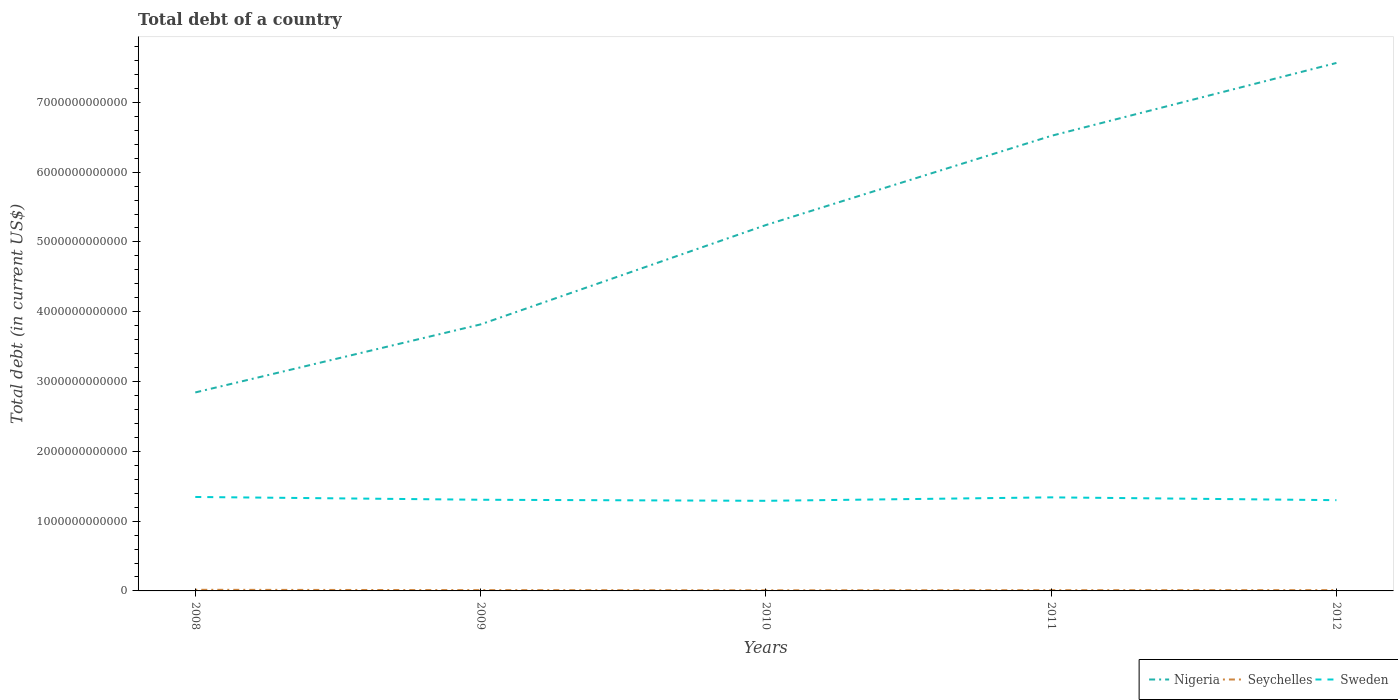Does the line corresponding to Seychelles intersect with the line corresponding to Sweden?
Make the answer very short. No. Is the number of lines equal to the number of legend labels?
Your answer should be compact. Yes. Across all years, what is the maximum debt in Sweden?
Make the answer very short. 1.29e+12. In which year was the debt in Seychelles maximum?
Your response must be concise. 2010. What is the total debt in Sweden in the graph?
Provide a short and direct response. 5.51e+1. What is the difference between the highest and the second highest debt in Seychelles?
Offer a terse response. 7.33e+09. Is the debt in Sweden strictly greater than the debt in Nigeria over the years?
Your answer should be compact. Yes. What is the difference between two consecutive major ticks on the Y-axis?
Provide a short and direct response. 1.00e+12. Are the values on the major ticks of Y-axis written in scientific E-notation?
Make the answer very short. No. Does the graph contain grids?
Your answer should be very brief. No. Where does the legend appear in the graph?
Your answer should be compact. Bottom right. How many legend labels are there?
Your answer should be compact. 3. What is the title of the graph?
Make the answer very short. Total debt of a country. Does "Sierra Leone" appear as one of the legend labels in the graph?
Keep it short and to the point. No. What is the label or title of the Y-axis?
Keep it short and to the point. Total debt (in current US$). What is the Total debt (in current US$) of Nigeria in 2008?
Your response must be concise. 2.84e+12. What is the Total debt (in current US$) of Seychelles in 2008?
Offer a terse response. 1.62e+1. What is the Total debt (in current US$) of Sweden in 2008?
Provide a succinct answer. 1.35e+12. What is the Total debt (in current US$) of Nigeria in 2009?
Provide a succinct answer. 3.82e+12. What is the Total debt (in current US$) of Seychelles in 2009?
Your answer should be compact. 1.16e+1. What is the Total debt (in current US$) of Sweden in 2009?
Offer a very short reply. 1.31e+12. What is the Total debt (in current US$) of Nigeria in 2010?
Give a very brief answer. 5.24e+12. What is the Total debt (in current US$) in Seychelles in 2010?
Offer a very short reply. 8.84e+09. What is the Total debt (in current US$) in Sweden in 2010?
Your response must be concise. 1.29e+12. What is the Total debt (in current US$) of Nigeria in 2011?
Provide a short and direct response. 6.52e+12. What is the Total debt (in current US$) of Seychelles in 2011?
Your answer should be compact. 1.04e+1. What is the Total debt (in current US$) of Sweden in 2011?
Offer a very short reply. 1.34e+12. What is the Total debt (in current US$) of Nigeria in 2012?
Keep it short and to the point. 7.56e+12. What is the Total debt (in current US$) in Seychelles in 2012?
Your response must be concise. 1.13e+1. What is the Total debt (in current US$) of Sweden in 2012?
Keep it short and to the point. 1.30e+12. Across all years, what is the maximum Total debt (in current US$) of Nigeria?
Your response must be concise. 7.56e+12. Across all years, what is the maximum Total debt (in current US$) in Seychelles?
Keep it short and to the point. 1.62e+1. Across all years, what is the maximum Total debt (in current US$) of Sweden?
Ensure brevity in your answer.  1.35e+12. Across all years, what is the minimum Total debt (in current US$) of Nigeria?
Offer a terse response. 2.84e+12. Across all years, what is the minimum Total debt (in current US$) of Seychelles?
Your answer should be very brief. 8.84e+09. Across all years, what is the minimum Total debt (in current US$) of Sweden?
Ensure brevity in your answer.  1.29e+12. What is the total Total debt (in current US$) in Nigeria in the graph?
Offer a very short reply. 2.60e+13. What is the total Total debt (in current US$) in Seychelles in the graph?
Ensure brevity in your answer.  5.83e+1. What is the total Total debt (in current US$) in Sweden in the graph?
Your answer should be very brief. 6.58e+12. What is the difference between the Total debt (in current US$) of Nigeria in 2008 and that in 2009?
Offer a terse response. -9.75e+11. What is the difference between the Total debt (in current US$) of Seychelles in 2008 and that in 2009?
Offer a very short reply. 4.60e+09. What is the difference between the Total debt (in current US$) in Sweden in 2008 and that in 2009?
Ensure brevity in your answer.  3.99e+1. What is the difference between the Total debt (in current US$) in Nigeria in 2008 and that in 2010?
Offer a terse response. -2.40e+12. What is the difference between the Total debt (in current US$) in Seychelles in 2008 and that in 2010?
Keep it short and to the point. 7.33e+09. What is the difference between the Total debt (in current US$) in Sweden in 2008 and that in 2010?
Keep it short and to the point. 5.51e+1. What is the difference between the Total debt (in current US$) in Nigeria in 2008 and that in 2011?
Give a very brief answer. -3.68e+12. What is the difference between the Total debt (in current US$) of Seychelles in 2008 and that in 2011?
Give a very brief answer. 5.77e+09. What is the difference between the Total debt (in current US$) of Sweden in 2008 and that in 2011?
Keep it short and to the point. 5.63e+09. What is the difference between the Total debt (in current US$) of Nigeria in 2008 and that in 2012?
Ensure brevity in your answer.  -4.72e+12. What is the difference between the Total debt (in current US$) of Seychelles in 2008 and that in 2012?
Ensure brevity in your answer.  4.83e+09. What is the difference between the Total debt (in current US$) of Sweden in 2008 and that in 2012?
Your response must be concise. 4.57e+1. What is the difference between the Total debt (in current US$) of Nigeria in 2009 and that in 2010?
Ensure brevity in your answer.  -1.42e+12. What is the difference between the Total debt (in current US$) of Seychelles in 2009 and that in 2010?
Ensure brevity in your answer.  2.73e+09. What is the difference between the Total debt (in current US$) of Sweden in 2009 and that in 2010?
Provide a succinct answer. 1.52e+1. What is the difference between the Total debt (in current US$) in Nigeria in 2009 and that in 2011?
Offer a terse response. -2.70e+12. What is the difference between the Total debt (in current US$) in Seychelles in 2009 and that in 2011?
Offer a very short reply. 1.17e+09. What is the difference between the Total debt (in current US$) of Sweden in 2009 and that in 2011?
Your response must be concise. -3.42e+1. What is the difference between the Total debt (in current US$) in Nigeria in 2009 and that in 2012?
Offer a terse response. -3.75e+12. What is the difference between the Total debt (in current US$) in Seychelles in 2009 and that in 2012?
Provide a short and direct response. 2.27e+08. What is the difference between the Total debt (in current US$) in Sweden in 2009 and that in 2012?
Keep it short and to the point. 5.87e+09. What is the difference between the Total debt (in current US$) in Nigeria in 2010 and that in 2011?
Your answer should be very brief. -1.28e+12. What is the difference between the Total debt (in current US$) of Seychelles in 2010 and that in 2011?
Your answer should be compact. -1.56e+09. What is the difference between the Total debt (in current US$) in Sweden in 2010 and that in 2011?
Keep it short and to the point. -4.94e+1. What is the difference between the Total debt (in current US$) of Nigeria in 2010 and that in 2012?
Your response must be concise. -2.32e+12. What is the difference between the Total debt (in current US$) of Seychelles in 2010 and that in 2012?
Make the answer very short. -2.50e+09. What is the difference between the Total debt (in current US$) in Sweden in 2010 and that in 2012?
Ensure brevity in your answer.  -9.33e+09. What is the difference between the Total debt (in current US$) of Nigeria in 2011 and that in 2012?
Give a very brief answer. -1.04e+12. What is the difference between the Total debt (in current US$) of Seychelles in 2011 and that in 2012?
Make the answer very short. -9.42e+08. What is the difference between the Total debt (in current US$) of Sweden in 2011 and that in 2012?
Offer a terse response. 4.01e+1. What is the difference between the Total debt (in current US$) of Nigeria in 2008 and the Total debt (in current US$) of Seychelles in 2009?
Give a very brief answer. 2.83e+12. What is the difference between the Total debt (in current US$) of Nigeria in 2008 and the Total debt (in current US$) of Sweden in 2009?
Your response must be concise. 1.54e+12. What is the difference between the Total debt (in current US$) in Seychelles in 2008 and the Total debt (in current US$) in Sweden in 2009?
Ensure brevity in your answer.  -1.29e+12. What is the difference between the Total debt (in current US$) in Nigeria in 2008 and the Total debt (in current US$) in Seychelles in 2010?
Your answer should be compact. 2.83e+12. What is the difference between the Total debt (in current US$) in Nigeria in 2008 and the Total debt (in current US$) in Sweden in 2010?
Provide a short and direct response. 1.55e+12. What is the difference between the Total debt (in current US$) of Seychelles in 2008 and the Total debt (in current US$) of Sweden in 2010?
Keep it short and to the point. -1.27e+12. What is the difference between the Total debt (in current US$) in Nigeria in 2008 and the Total debt (in current US$) in Seychelles in 2011?
Offer a terse response. 2.83e+12. What is the difference between the Total debt (in current US$) in Nigeria in 2008 and the Total debt (in current US$) in Sweden in 2011?
Provide a short and direct response. 1.50e+12. What is the difference between the Total debt (in current US$) in Seychelles in 2008 and the Total debt (in current US$) in Sweden in 2011?
Provide a succinct answer. -1.32e+12. What is the difference between the Total debt (in current US$) in Nigeria in 2008 and the Total debt (in current US$) in Seychelles in 2012?
Your response must be concise. 2.83e+12. What is the difference between the Total debt (in current US$) in Nigeria in 2008 and the Total debt (in current US$) in Sweden in 2012?
Provide a succinct answer. 1.54e+12. What is the difference between the Total debt (in current US$) of Seychelles in 2008 and the Total debt (in current US$) of Sweden in 2012?
Your answer should be compact. -1.28e+12. What is the difference between the Total debt (in current US$) of Nigeria in 2009 and the Total debt (in current US$) of Seychelles in 2010?
Your answer should be compact. 3.81e+12. What is the difference between the Total debt (in current US$) of Nigeria in 2009 and the Total debt (in current US$) of Sweden in 2010?
Your answer should be very brief. 2.53e+12. What is the difference between the Total debt (in current US$) of Seychelles in 2009 and the Total debt (in current US$) of Sweden in 2010?
Provide a short and direct response. -1.28e+12. What is the difference between the Total debt (in current US$) of Nigeria in 2009 and the Total debt (in current US$) of Seychelles in 2011?
Make the answer very short. 3.81e+12. What is the difference between the Total debt (in current US$) in Nigeria in 2009 and the Total debt (in current US$) in Sweden in 2011?
Make the answer very short. 2.48e+12. What is the difference between the Total debt (in current US$) in Seychelles in 2009 and the Total debt (in current US$) in Sweden in 2011?
Your answer should be compact. -1.33e+12. What is the difference between the Total debt (in current US$) in Nigeria in 2009 and the Total debt (in current US$) in Seychelles in 2012?
Offer a very short reply. 3.81e+12. What is the difference between the Total debt (in current US$) in Nigeria in 2009 and the Total debt (in current US$) in Sweden in 2012?
Give a very brief answer. 2.52e+12. What is the difference between the Total debt (in current US$) of Seychelles in 2009 and the Total debt (in current US$) of Sweden in 2012?
Your answer should be compact. -1.29e+12. What is the difference between the Total debt (in current US$) of Nigeria in 2010 and the Total debt (in current US$) of Seychelles in 2011?
Keep it short and to the point. 5.23e+12. What is the difference between the Total debt (in current US$) of Nigeria in 2010 and the Total debt (in current US$) of Sweden in 2011?
Your answer should be compact. 3.90e+12. What is the difference between the Total debt (in current US$) of Seychelles in 2010 and the Total debt (in current US$) of Sweden in 2011?
Your response must be concise. -1.33e+12. What is the difference between the Total debt (in current US$) in Nigeria in 2010 and the Total debt (in current US$) in Seychelles in 2012?
Offer a very short reply. 5.23e+12. What is the difference between the Total debt (in current US$) of Nigeria in 2010 and the Total debt (in current US$) of Sweden in 2012?
Provide a succinct answer. 3.94e+12. What is the difference between the Total debt (in current US$) of Seychelles in 2010 and the Total debt (in current US$) of Sweden in 2012?
Ensure brevity in your answer.  -1.29e+12. What is the difference between the Total debt (in current US$) in Nigeria in 2011 and the Total debt (in current US$) in Seychelles in 2012?
Provide a short and direct response. 6.51e+12. What is the difference between the Total debt (in current US$) of Nigeria in 2011 and the Total debt (in current US$) of Sweden in 2012?
Make the answer very short. 5.22e+12. What is the difference between the Total debt (in current US$) in Seychelles in 2011 and the Total debt (in current US$) in Sweden in 2012?
Offer a very short reply. -1.29e+12. What is the average Total debt (in current US$) in Nigeria per year?
Offer a very short reply. 5.20e+12. What is the average Total debt (in current US$) in Seychelles per year?
Give a very brief answer. 1.17e+1. What is the average Total debt (in current US$) of Sweden per year?
Provide a short and direct response. 1.32e+12. In the year 2008, what is the difference between the Total debt (in current US$) of Nigeria and Total debt (in current US$) of Seychelles?
Provide a short and direct response. 2.83e+12. In the year 2008, what is the difference between the Total debt (in current US$) in Nigeria and Total debt (in current US$) in Sweden?
Ensure brevity in your answer.  1.50e+12. In the year 2008, what is the difference between the Total debt (in current US$) in Seychelles and Total debt (in current US$) in Sweden?
Provide a succinct answer. -1.33e+12. In the year 2009, what is the difference between the Total debt (in current US$) of Nigeria and Total debt (in current US$) of Seychelles?
Provide a succinct answer. 3.81e+12. In the year 2009, what is the difference between the Total debt (in current US$) in Nigeria and Total debt (in current US$) in Sweden?
Give a very brief answer. 2.51e+12. In the year 2009, what is the difference between the Total debt (in current US$) of Seychelles and Total debt (in current US$) of Sweden?
Ensure brevity in your answer.  -1.29e+12. In the year 2010, what is the difference between the Total debt (in current US$) in Nigeria and Total debt (in current US$) in Seychelles?
Your answer should be compact. 5.23e+12. In the year 2010, what is the difference between the Total debt (in current US$) of Nigeria and Total debt (in current US$) of Sweden?
Make the answer very short. 3.95e+12. In the year 2010, what is the difference between the Total debt (in current US$) of Seychelles and Total debt (in current US$) of Sweden?
Ensure brevity in your answer.  -1.28e+12. In the year 2011, what is the difference between the Total debt (in current US$) in Nigeria and Total debt (in current US$) in Seychelles?
Ensure brevity in your answer.  6.51e+12. In the year 2011, what is the difference between the Total debt (in current US$) of Nigeria and Total debt (in current US$) of Sweden?
Give a very brief answer. 5.18e+12. In the year 2011, what is the difference between the Total debt (in current US$) of Seychelles and Total debt (in current US$) of Sweden?
Your answer should be compact. -1.33e+12. In the year 2012, what is the difference between the Total debt (in current US$) of Nigeria and Total debt (in current US$) of Seychelles?
Ensure brevity in your answer.  7.55e+12. In the year 2012, what is the difference between the Total debt (in current US$) in Nigeria and Total debt (in current US$) in Sweden?
Keep it short and to the point. 6.26e+12. In the year 2012, what is the difference between the Total debt (in current US$) in Seychelles and Total debt (in current US$) in Sweden?
Give a very brief answer. -1.29e+12. What is the ratio of the Total debt (in current US$) of Nigeria in 2008 to that in 2009?
Ensure brevity in your answer.  0.74. What is the ratio of the Total debt (in current US$) of Seychelles in 2008 to that in 2009?
Your answer should be very brief. 1.4. What is the ratio of the Total debt (in current US$) of Sweden in 2008 to that in 2009?
Offer a terse response. 1.03. What is the ratio of the Total debt (in current US$) of Nigeria in 2008 to that in 2010?
Give a very brief answer. 0.54. What is the ratio of the Total debt (in current US$) of Seychelles in 2008 to that in 2010?
Your response must be concise. 1.83. What is the ratio of the Total debt (in current US$) in Sweden in 2008 to that in 2010?
Make the answer very short. 1.04. What is the ratio of the Total debt (in current US$) of Nigeria in 2008 to that in 2011?
Ensure brevity in your answer.  0.44. What is the ratio of the Total debt (in current US$) in Seychelles in 2008 to that in 2011?
Your answer should be compact. 1.55. What is the ratio of the Total debt (in current US$) of Sweden in 2008 to that in 2011?
Your answer should be compact. 1. What is the ratio of the Total debt (in current US$) of Nigeria in 2008 to that in 2012?
Your answer should be compact. 0.38. What is the ratio of the Total debt (in current US$) in Seychelles in 2008 to that in 2012?
Provide a short and direct response. 1.43. What is the ratio of the Total debt (in current US$) of Sweden in 2008 to that in 2012?
Your response must be concise. 1.04. What is the ratio of the Total debt (in current US$) in Nigeria in 2009 to that in 2010?
Give a very brief answer. 0.73. What is the ratio of the Total debt (in current US$) of Seychelles in 2009 to that in 2010?
Ensure brevity in your answer.  1.31. What is the ratio of the Total debt (in current US$) in Sweden in 2009 to that in 2010?
Offer a very short reply. 1.01. What is the ratio of the Total debt (in current US$) in Nigeria in 2009 to that in 2011?
Offer a very short reply. 0.59. What is the ratio of the Total debt (in current US$) in Seychelles in 2009 to that in 2011?
Make the answer very short. 1.11. What is the ratio of the Total debt (in current US$) in Sweden in 2009 to that in 2011?
Offer a very short reply. 0.97. What is the ratio of the Total debt (in current US$) in Nigeria in 2009 to that in 2012?
Your answer should be very brief. 0.5. What is the ratio of the Total debt (in current US$) in Seychelles in 2009 to that in 2012?
Provide a succinct answer. 1.02. What is the ratio of the Total debt (in current US$) of Nigeria in 2010 to that in 2011?
Offer a terse response. 0.8. What is the ratio of the Total debt (in current US$) in Seychelles in 2010 to that in 2011?
Ensure brevity in your answer.  0.85. What is the ratio of the Total debt (in current US$) in Sweden in 2010 to that in 2011?
Give a very brief answer. 0.96. What is the ratio of the Total debt (in current US$) of Nigeria in 2010 to that in 2012?
Give a very brief answer. 0.69. What is the ratio of the Total debt (in current US$) of Seychelles in 2010 to that in 2012?
Your answer should be very brief. 0.78. What is the ratio of the Total debt (in current US$) in Nigeria in 2011 to that in 2012?
Provide a succinct answer. 0.86. What is the ratio of the Total debt (in current US$) in Seychelles in 2011 to that in 2012?
Make the answer very short. 0.92. What is the ratio of the Total debt (in current US$) in Sweden in 2011 to that in 2012?
Provide a succinct answer. 1.03. What is the difference between the highest and the second highest Total debt (in current US$) in Nigeria?
Offer a very short reply. 1.04e+12. What is the difference between the highest and the second highest Total debt (in current US$) of Seychelles?
Offer a very short reply. 4.60e+09. What is the difference between the highest and the second highest Total debt (in current US$) in Sweden?
Your response must be concise. 5.63e+09. What is the difference between the highest and the lowest Total debt (in current US$) in Nigeria?
Ensure brevity in your answer.  4.72e+12. What is the difference between the highest and the lowest Total debt (in current US$) of Seychelles?
Offer a very short reply. 7.33e+09. What is the difference between the highest and the lowest Total debt (in current US$) in Sweden?
Your response must be concise. 5.51e+1. 